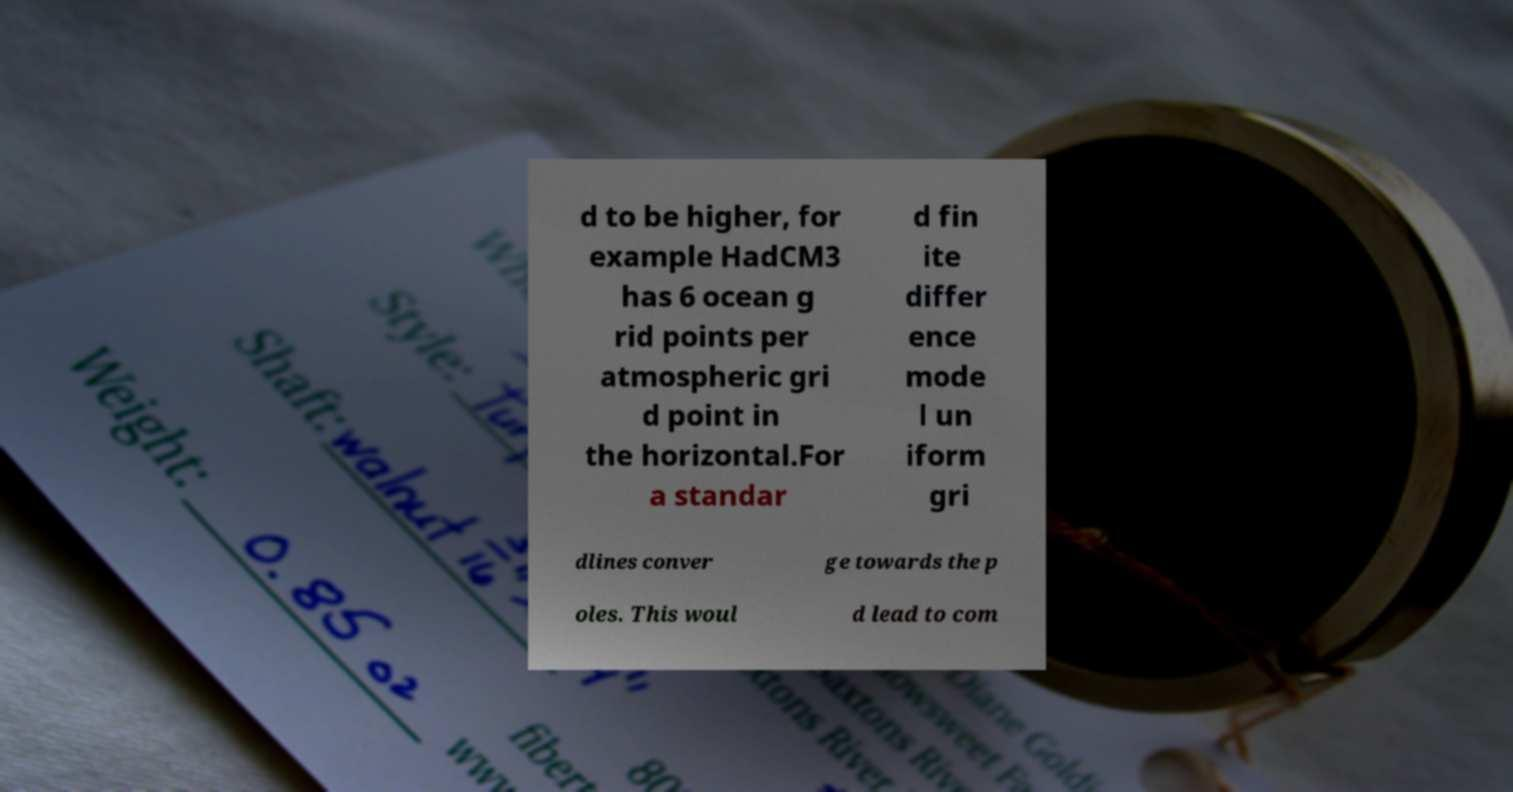There's text embedded in this image that I need extracted. Can you transcribe it verbatim? d to be higher, for example HadCM3 has 6 ocean g rid points per atmospheric gri d point in the horizontal.For a standar d fin ite differ ence mode l un iform gri dlines conver ge towards the p oles. This woul d lead to com 